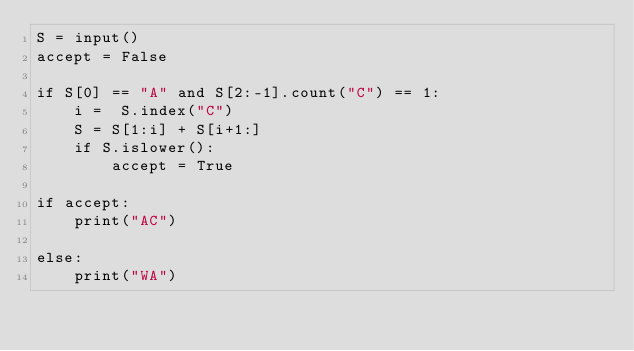<code> <loc_0><loc_0><loc_500><loc_500><_Python_>S = input()
accept = False

if S[0] == "A" and S[2:-1].count("C") == 1:
    i =  S.index("C")
    S = S[1:i] + S[i+1:]
    if S.islower():
        accept = True

if accept:
    print("AC")

else:
    print("WA")</code> 